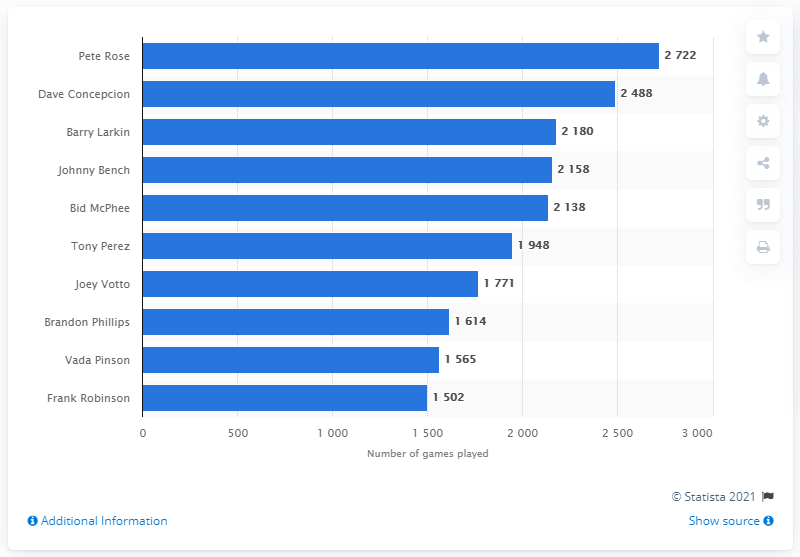Draw attention to some important aspects in this diagram. The Cincinnati Reds franchise history has been played by Pete Rose, who has played the most number of games. 